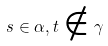<formula> <loc_0><loc_0><loc_500><loc_500>s \in \alpha , t \notin \gamma</formula> 